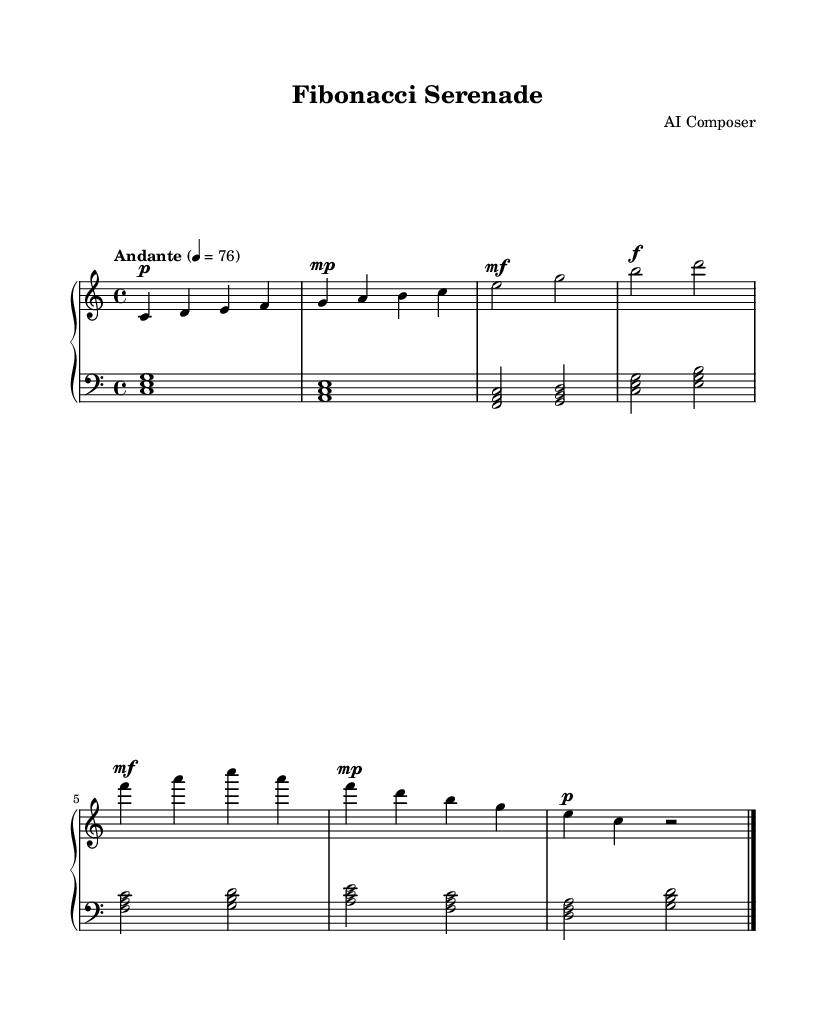What is the key signature of this music? The key signature is determined by looking at the sharp and flat indicators at the beginning of the staff. Here, there are no sharps or flats present, which identifies it as C major.
Answer: C major What is the time signature of this music? The time signature indicates how many beats are in a measure and what note value is given one beat. Here, the time signature is written as 4/4, meaning there are four beats per measure, and the quarter note receives one beat.
Answer: 4/4 What is the tempo marking of this piece? The tempo marking explains the speed of the piece. Upon examining the music, it reads "Andante" with a metronome marking of 76, which indicates a moderate walking pace.
Answer: Andante, 76 How many measures does the music consist of? To find the number of measures, we count the vertical lines on the staff that separate the music into groups. The music has a total of 8 measures.
Answer: 8 What is the dynamic marking in the first measure? The dynamic marking indicates the volume level for the music. In the first measure, the marking is "p," which stands for "piano," meaning soft.
Answer: piano Which repetitive harmonic structure can be found in the left hand? The left hand contains accompanying chords that are structured in a manner that repeats the pattern of C major triads and its related chords. The first chord in every measure features a root position triad.
Answer: C major triads Which mathematical sequence partially inspired the melody's structure? The title "Fibonacci Serenade" suggests that the music is influenced by the Fibonacci sequence. The pattern of note lengths and placement may reflect the ratios and numbers from this sequence conceptually.
Answer: Fibonacci sequence 